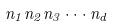Convert formula to latex. <formula><loc_0><loc_0><loc_500><loc_500>n _ { 1 } n _ { 2 } n _ { 3 } \cdot \cdot \cdot n _ { d }</formula> 